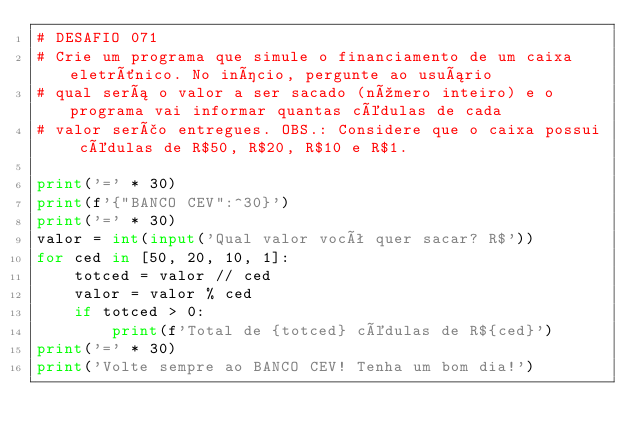<code> <loc_0><loc_0><loc_500><loc_500><_Python_># DESAFIO 071
# Crie um programa que simule o financiamento de um caixa eletrônico. No início, pergunte ao usuário
# qual será o valor a ser sacado (número inteiro) e o programa vai informar quantas cédulas de cada
# valor serão entregues. OBS.: Considere que o caixa possui cédulas de R$50, R$20, R$10 e R$1.

print('=' * 30)
print(f'{"BANCO CEV":^30}')
print('=' * 30)
valor = int(input('Qual valor você quer sacar? R$'))
for ced in [50, 20, 10, 1]:
    totced = valor // ced
    valor = valor % ced
    if totced > 0:
        print(f'Total de {totced} cédulas de R${ced}')
print('=' * 30)
print('Volte sempre ao BANCO CEV! Tenha um bom dia!')
</code> 